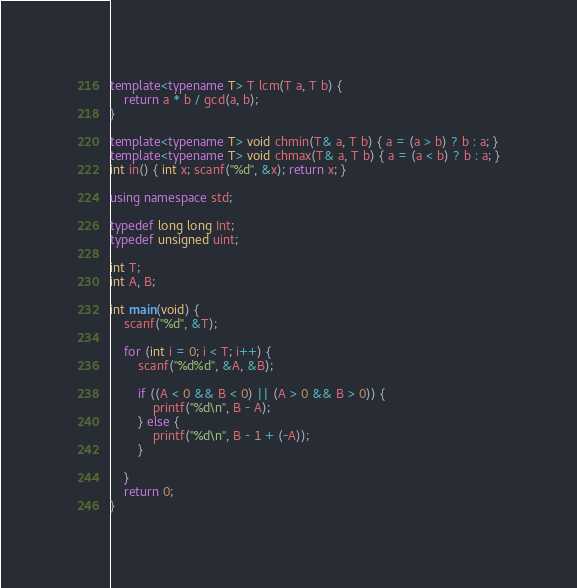<code> <loc_0><loc_0><loc_500><loc_500><_C++_>template<typename T> T lcm(T a, T b) {
    return a * b / gcd(a, b);
}

template<typename T> void chmin(T& a, T b) { a = (a > b) ? b : a; }
template<typename T> void chmax(T& a, T b) { a = (a < b) ? b : a; }
int in() { int x; scanf("%d", &x); return x; }

using namespace std;

typedef long long Int;
typedef unsigned uint;

int T;
int A, B;

int main(void) {
	scanf("%d", &T);
	
	for (int i = 0; i < T; i++) {
		scanf("%d%d", &A, &B);

		if ((A < 0 && B < 0) || (A > 0 && B > 0)) {
			printf("%d\n", B - A);
		} else {
			printf("%d\n", B - 1 + (-A));
		}
		
	}
    return 0;
}
</code> 